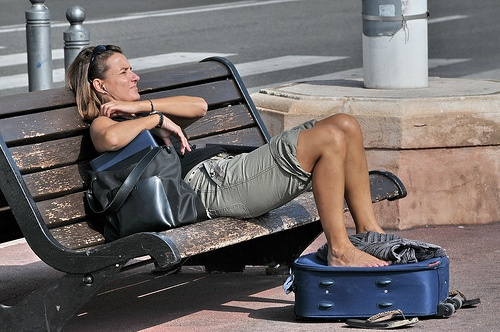Describe the objects in this image and their specific colors. I can see bench in gray, black, and darkgray tones, people in gray, black, and darkgray tones, suitcase in gray, navy, darkblue, and black tones, handbag in gray, black, and darkblue tones, and laptop in gray, black, darkblue, and navy tones in this image. 